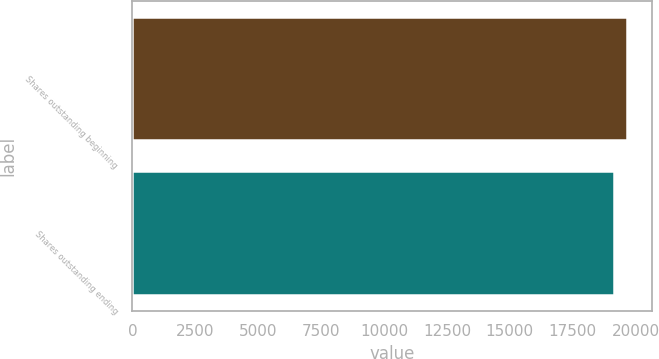Convert chart to OTSL. <chart><loc_0><loc_0><loc_500><loc_500><bar_chart><fcel>Shares outstanding beginning<fcel>Shares outstanding ending<nl><fcel>19660<fcel>19160<nl></chart> 